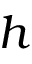Convert formula to latex. <formula><loc_0><loc_0><loc_500><loc_500>h</formula> 